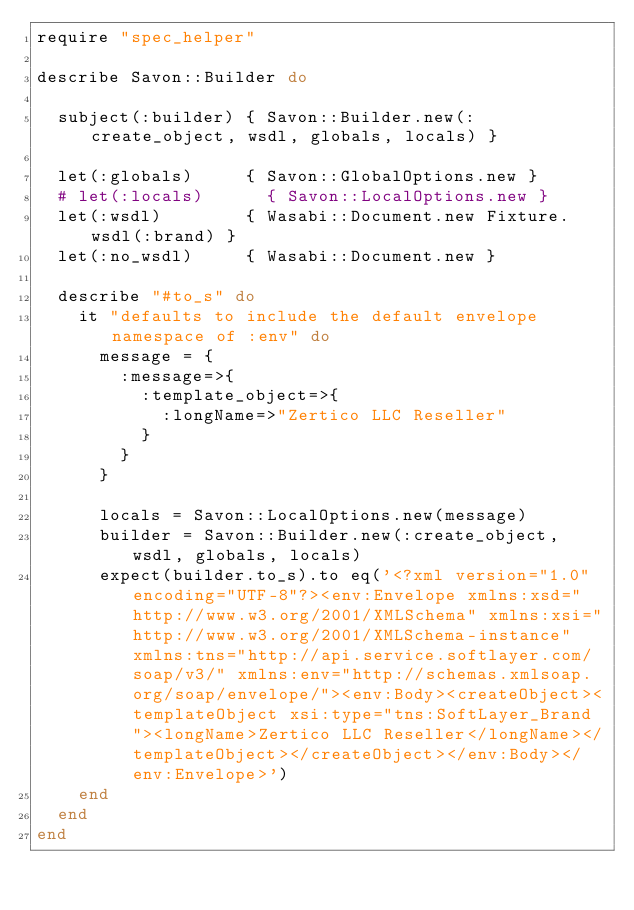Convert code to text. <code><loc_0><loc_0><loc_500><loc_500><_Ruby_>require "spec_helper"

describe Savon::Builder do

  subject(:builder) { Savon::Builder.new(:create_object, wsdl, globals, locals) }

  let(:globals)     { Savon::GlobalOptions.new }
  # let(:locals)      { Savon::LocalOptions.new }
  let(:wsdl)        { Wasabi::Document.new Fixture.wsdl(:brand) }
  let(:no_wsdl)     { Wasabi::Document.new }

  describe "#to_s" do
    it "defaults to include the default envelope namespace of :env" do
      message = {
        :message=>{
          :template_object=>{
            :longName=>"Zertico LLC Reseller"
          }
        }
      }

      locals = Savon::LocalOptions.new(message)
      builder = Savon::Builder.new(:create_object, wsdl, globals, locals)
      expect(builder.to_s).to eq('<?xml version="1.0" encoding="UTF-8"?><env:Envelope xmlns:xsd="http://www.w3.org/2001/XMLSchema" xmlns:xsi="http://www.w3.org/2001/XMLSchema-instance" xmlns:tns="http://api.service.softlayer.com/soap/v3/" xmlns:env="http://schemas.xmlsoap.org/soap/envelope/"><env:Body><createObject><templateObject xsi:type="tns:SoftLayer_Brand"><longName>Zertico LLC Reseller</longName></templateObject></createObject></env:Body></env:Envelope>')
    end
  end
end
</code> 